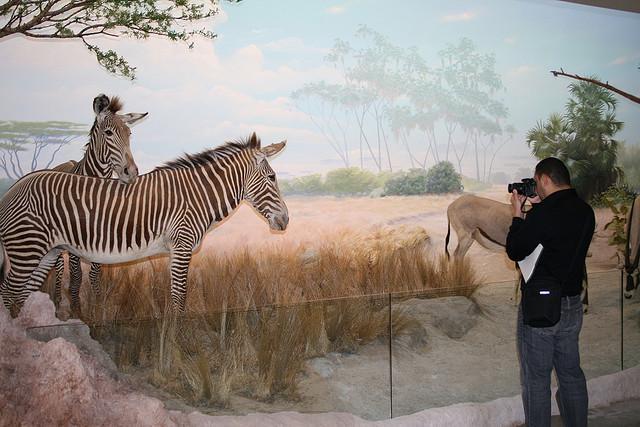How many zebras are there?
Give a very brief answer. 2. 